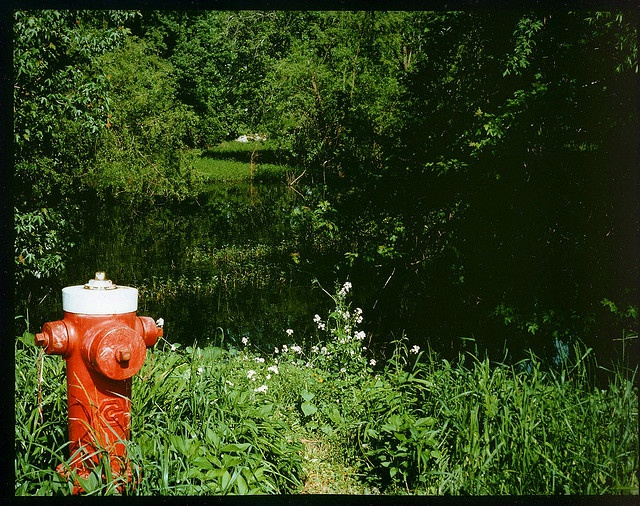Describe the objects in this image and their specific colors. I can see a fire hydrant in black, red, white, and brown tones in this image. 